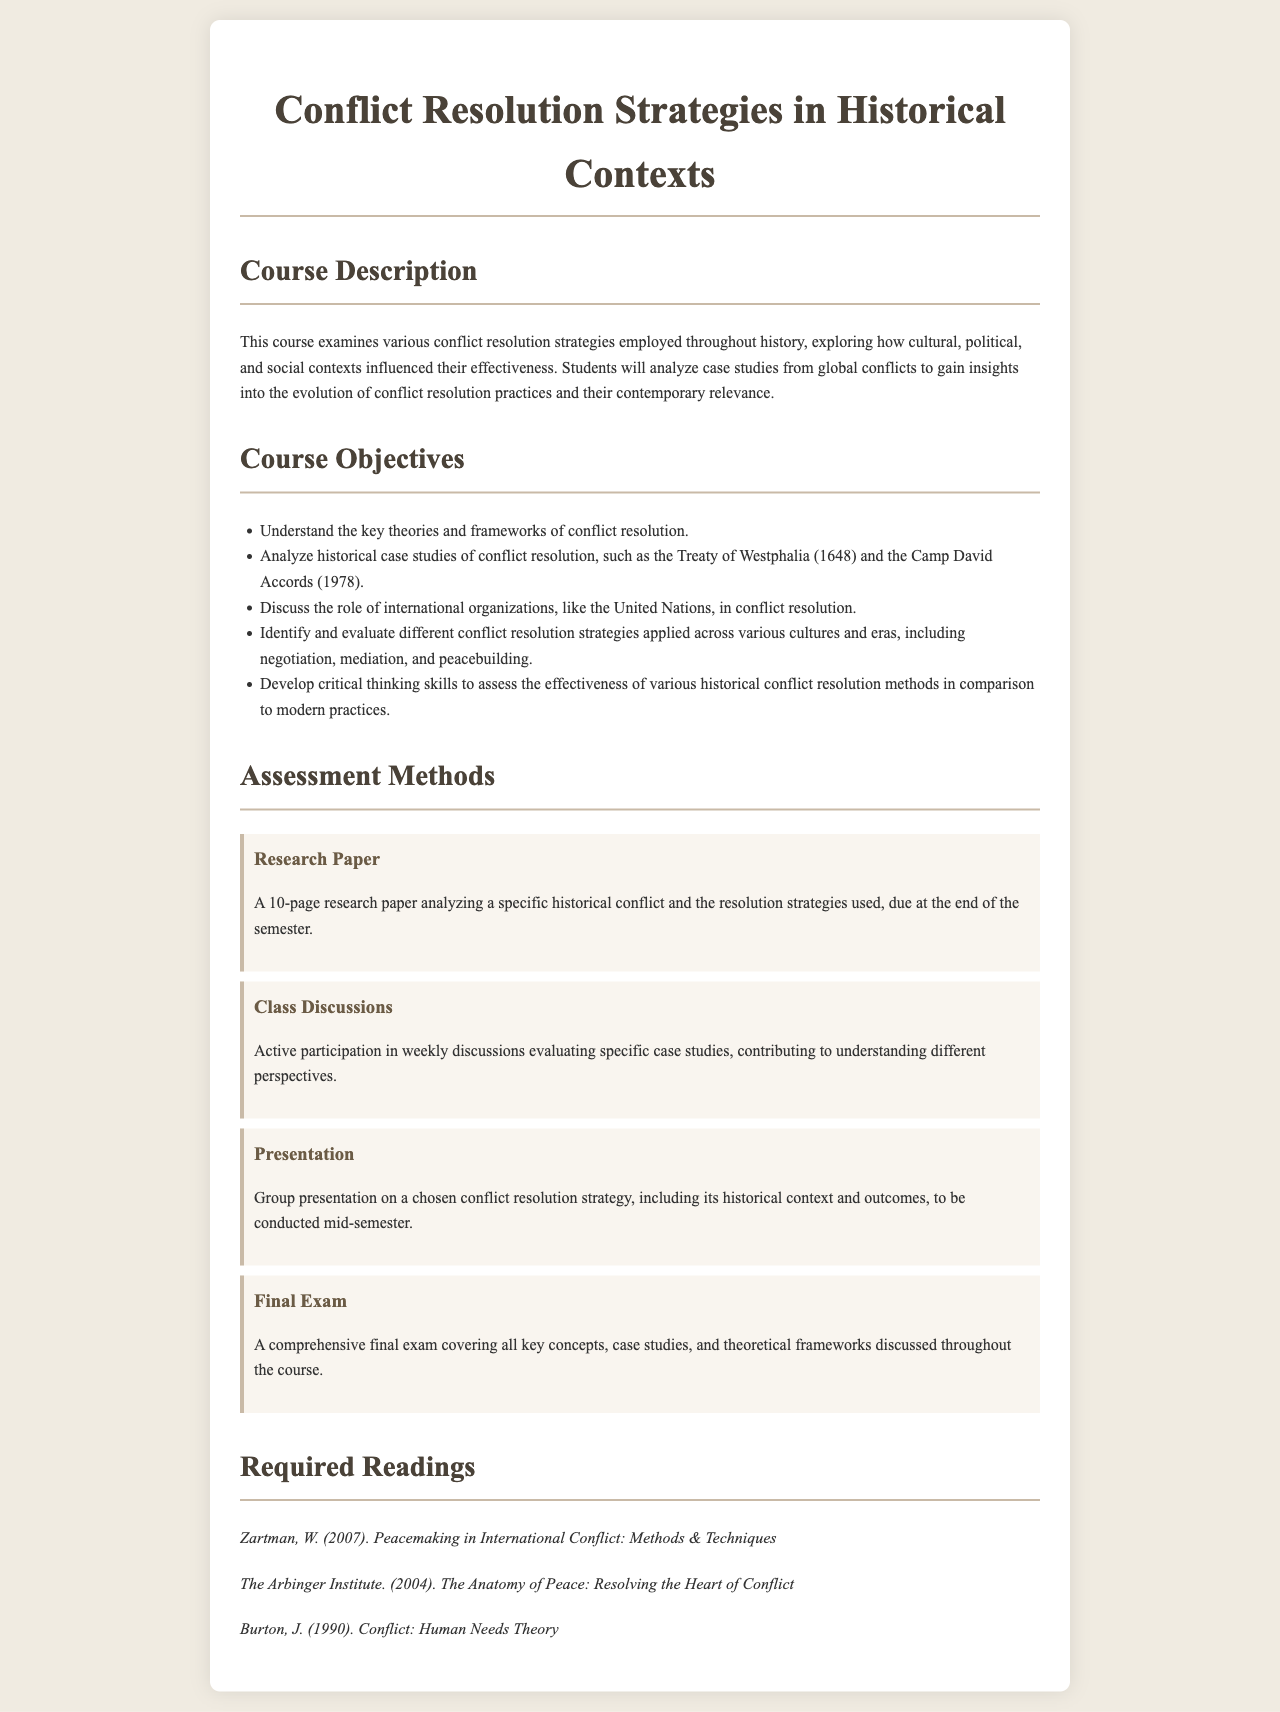What is the title of the course? The title of the course is found in the header of the document.
Answer: Conflict Resolution Strategies in Historical Contexts What is one key theory discussed in the course objectives? The course objectives list key theories related to conflict resolution.
Answer: key theories and frameworks of conflict resolution What is the due date for the research paper? The document states that the research paper is due at the end of the semester.
Answer: end of the semester Name one required reading for the course. The required readings section lists multiple texts; one can be cited.
Answer: Zartman, W. (2007). Peacemaking in International Conflict: Methods & Techniques What type of assessment involves group work? The assessment methods describe different assessments; this one outlines group work.
Answer: Group presentation How many pages is the research paper? The assessment method specifies the length of the research paper.
Answer: 10-page What historical context is analyzed in the course objectives? The document mentions specific historical events in the course objectives for analysis.
Answer: Treaty of Westphalia (1648) How is class participation evaluated? Class discussions involve evaluating specific case studies, indicating how participation is assessed.
Answer: Active participation in weekly discussions What are the roles of international organizations mentioned? The course objectives include discussion on a specific type of organization.
Answer: role of international organizations, like the United Nations What is the focus of the final exam? The assessment methods describe the final exam's coverage of course materials.
Answer: key concepts, case studies, and theoretical frameworks 